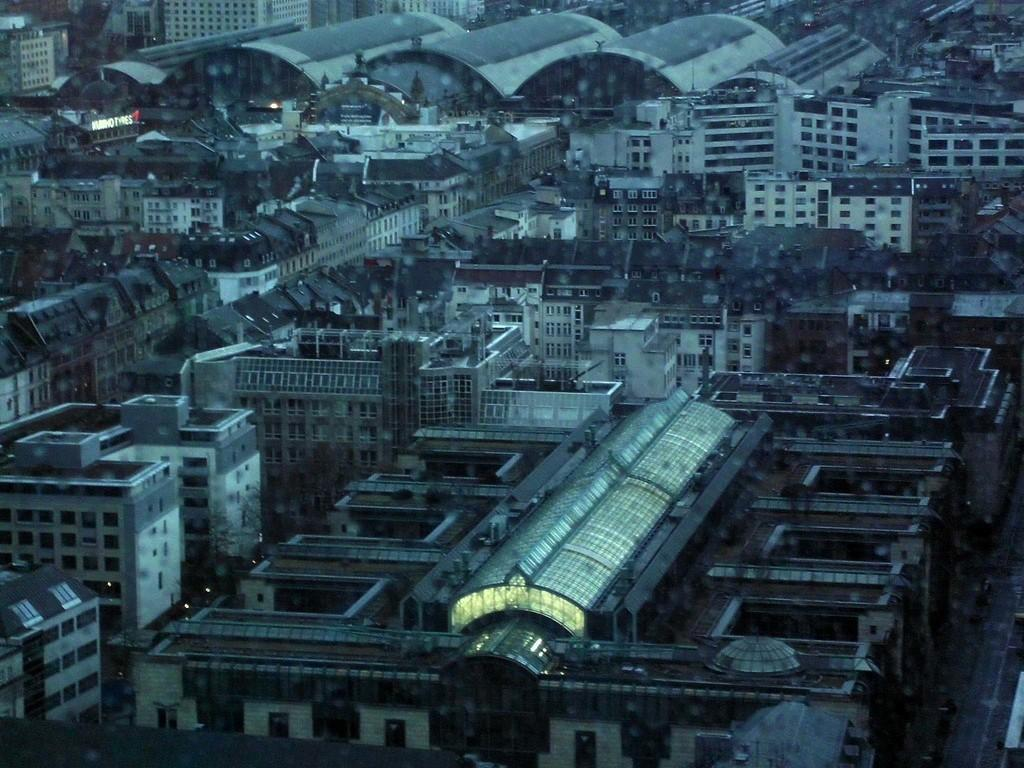What type of structures can be seen in the image? There are buildings in the image. What type of baseball equipment can be seen in the image? There is no baseball equipment present in the image; it only features buildings. What type of paste is being used to create the buildings in the image? The image is not a drawing or model, so there is no paste involved in creating the buildings. 